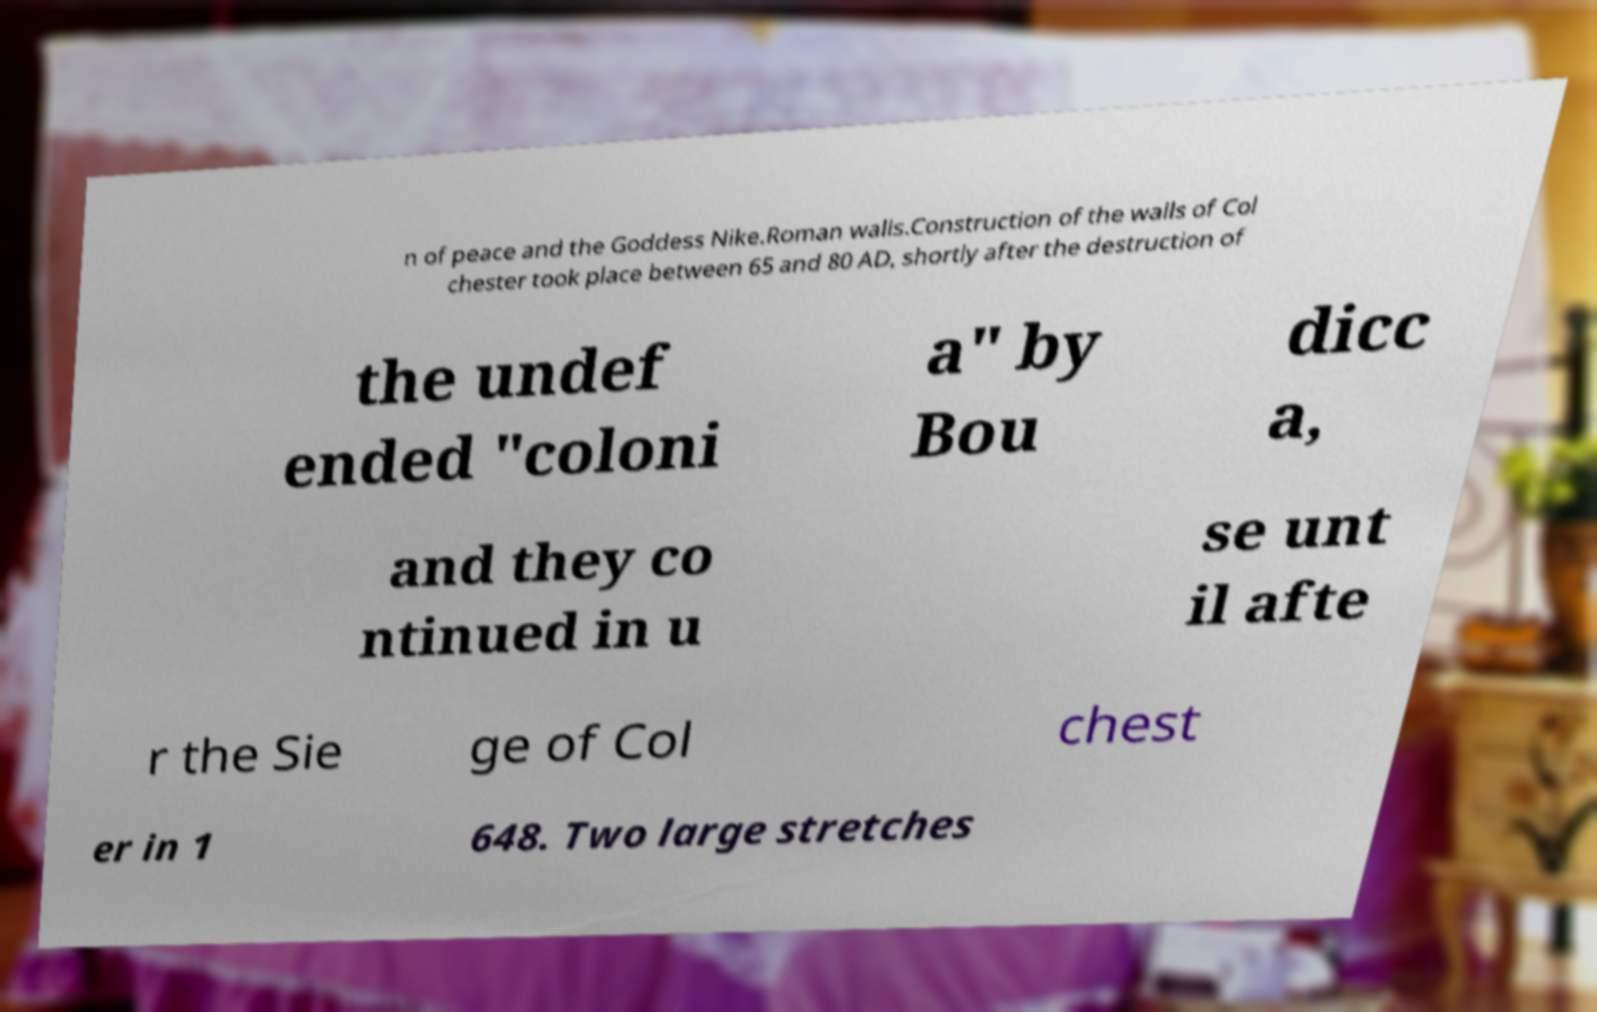Could you extract and type out the text from this image? n of peace and the Goddess Nike.Roman walls.Construction of the walls of Col chester took place between 65 and 80 AD, shortly after the destruction of the undef ended "coloni a" by Bou dicc a, and they co ntinued in u se unt il afte r the Sie ge of Col chest er in 1 648. Two large stretches 